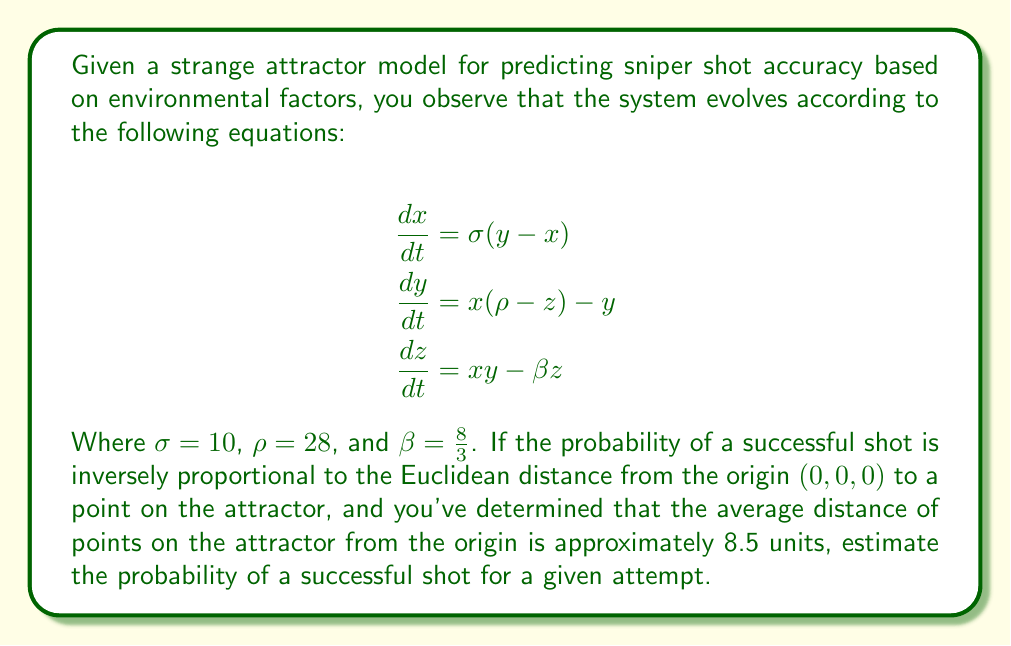Could you help me with this problem? To solve this problem, we'll follow these steps:

1) First, we recognize that the given equations describe the Lorenz attractor, a well-known strange attractor in chaos theory.

2) We're told that the probability of a successful shot is inversely proportional to the distance from the origin to a point on the attractor. This can be expressed mathematically as:

   $P(\text{successful shot}) \propto \frac{1}{d}$

   where $d$ is the distance from the origin to a point on the attractor.

3) We're given that the average distance of points on the attractor from the origin is approximately 8.5 units. Let's call this average distance $\bar{d}$.

4) To convert this inverse proportionality to an actual probability, we need to normalize it. The simplest way to do this is to assume that when $d = \bar{d}$, the probability is 0.5 (50%). This gives us:

   $P(\text{successful shot}) = \frac{\bar{d}}{2d}$

5) Now, for an average point on the attractor:

   $P(\text{successful shot}) = \frac{\bar{d}}{2\bar{d}} = \frac{8.5}{2(8.5)} = 0.5$

This confirms our normalization is correct.

6) Therefore, our final formula for the probability of a successful shot for any point on the attractor is:

   $P(\text{successful shot}) = \frac{8.5}{2d}$

7) For a given attempt, we expect the shot to correspond to an average point on the attractor, so we can use $d = \bar{d} = 8.5$:

   $P(\text{successful shot}) = \frac{8.5}{2(8.5)} = 0.5$

Thus, for a given attempt, we estimate the probability of a successful shot to be 0.5 or 50%.
Answer: 0.5 (or 50%) 